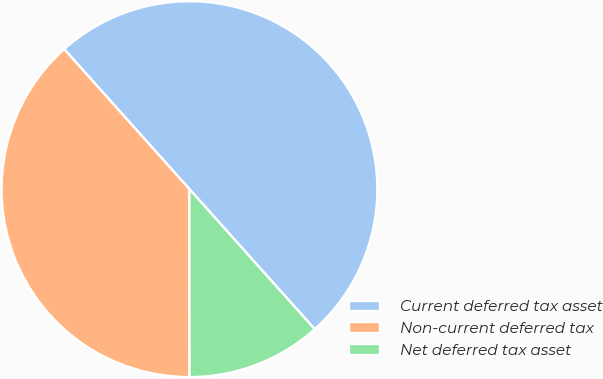Convert chart to OTSL. <chart><loc_0><loc_0><loc_500><loc_500><pie_chart><fcel>Current deferred tax asset<fcel>Non-current deferred tax<fcel>Net deferred tax asset<nl><fcel>50.0%<fcel>38.39%<fcel>11.61%<nl></chart> 